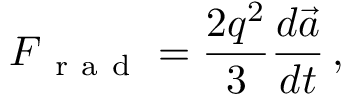Convert formula to latex. <formula><loc_0><loc_0><loc_500><loc_500>F _ { r a d } = \frac { 2 q ^ { 2 } } { 3 } \frac { d \vec { a } } { d t } \, ,</formula> 